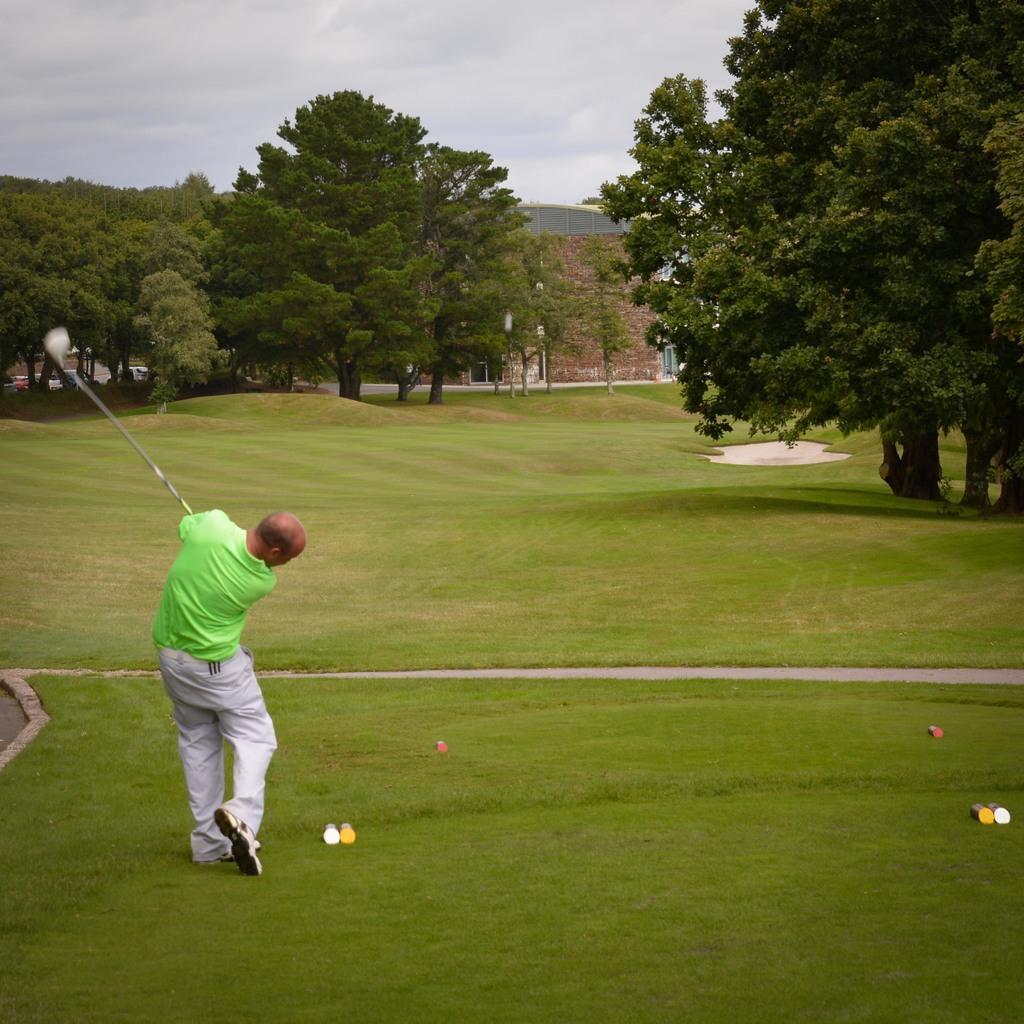Could you give a brief overview of what you see in this image? In this image there is a man standing on the ground. He is holding a golf stick in his hand. There is grass on the ground. In the background there are trees and a building. At the top there is the sky. 